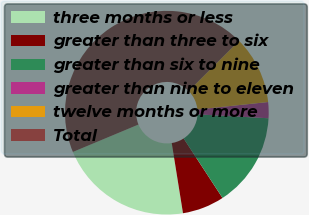Convert chart to OTSL. <chart><loc_0><loc_0><loc_500><loc_500><pie_chart><fcel>three months or less<fcel>greater than three to six<fcel>greater than six to nine<fcel>greater than nine to eleven<fcel>twelve months or more<fcel>Total<nl><fcel>21.24%<fcel>6.67%<fcel>14.93%<fcel>2.54%<fcel>10.8%<fcel>43.84%<nl></chart> 